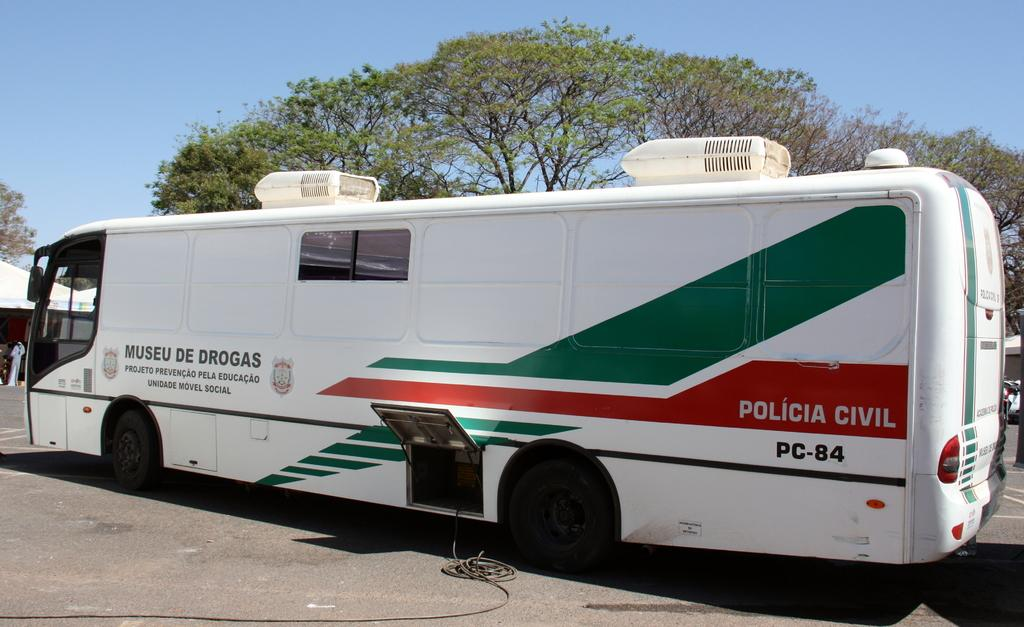<image>
Provide a brief description of the given image. White bus that says Museu De Drogas on the side parked by a tree. 